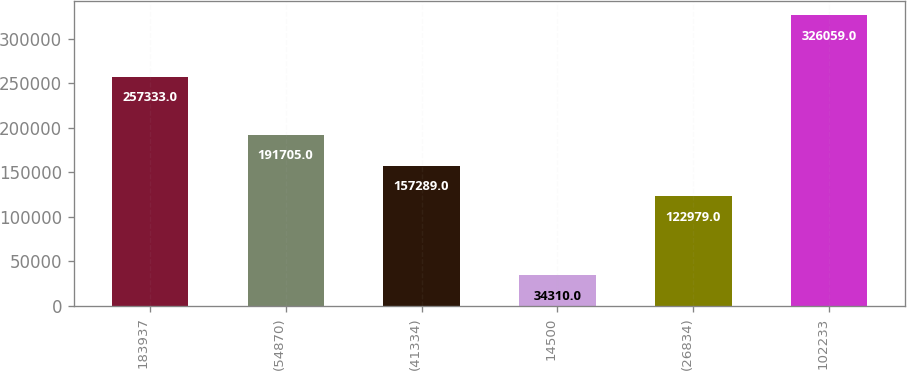<chart> <loc_0><loc_0><loc_500><loc_500><bar_chart><fcel>183937<fcel>(54870)<fcel>(41334)<fcel>14500<fcel>(26834)<fcel>102233<nl><fcel>257333<fcel>191705<fcel>157289<fcel>34310<fcel>122979<fcel>326059<nl></chart> 